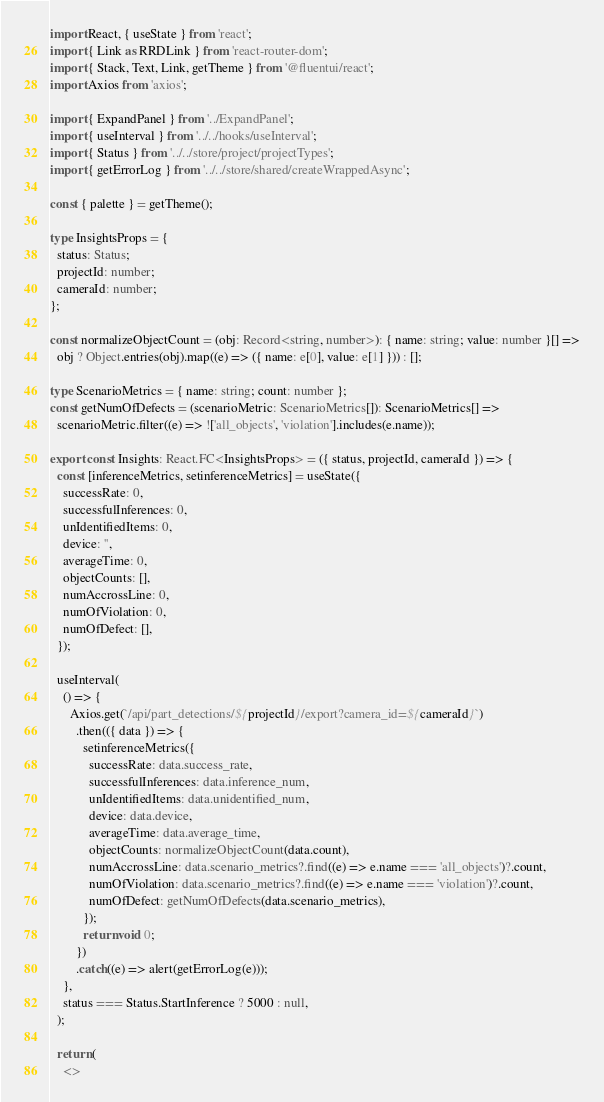<code> <loc_0><loc_0><loc_500><loc_500><_TypeScript_>import React, { useState } from 'react';
import { Link as RRDLink } from 'react-router-dom';
import { Stack, Text, Link, getTheme } from '@fluentui/react';
import Axios from 'axios';

import { ExpandPanel } from '../ExpandPanel';
import { useInterval } from '../../hooks/useInterval';
import { Status } from '../../store/project/projectTypes';
import { getErrorLog } from '../../store/shared/createWrappedAsync';

const { palette } = getTheme();

type InsightsProps = {
  status: Status;
  projectId: number;
  cameraId: number;
};

const normalizeObjectCount = (obj: Record<string, number>): { name: string; value: number }[] =>
  obj ? Object.entries(obj).map((e) => ({ name: e[0], value: e[1] })) : [];

type ScenarioMetrics = { name: string; count: number };
const getNumOfDefects = (scenarioMetric: ScenarioMetrics[]): ScenarioMetrics[] =>
  scenarioMetric.filter((e) => !['all_objects', 'violation'].includes(e.name));

export const Insights: React.FC<InsightsProps> = ({ status, projectId, cameraId }) => {
  const [inferenceMetrics, setinferenceMetrics] = useState({
    successRate: 0,
    successfulInferences: 0,
    unIdentifiedItems: 0,
    device: '',
    averageTime: 0,
    objectCounts: [],
    numAccrossLine: 0,
    numOfViolation: 0,
    numOfDefect: [],
  });

  useInterval(
    () => {
      Axios.get(`/api/part_detections/${projectId}/export?camera_id=${cameraId}`)
        .then(({ data }) => {
          setinferenceMetrics({
            successRate: data.success_rate,
            successfulInferences: data.inference_num,
            unIdentifiedItems: data.unidentified_num,
            device: data.device,
            averageTime: data.average_time,
            objectCounts: normalizeObjectCount(data.count),
            numAccrossLine: data.scenario_metrics?.find((e) => e.name === 'all_objects')?.count,
            numOfViolation: data.scenario_metrics?.find((e) => e.name === 'violation')?.count,
            numOfDefect: getNumOfDefects(data.scenario_metrics),
          });
          return void 0;
        })
        .catch((e) => alert(getErrorLog(e)));
    },
    status === Status.StartInference ? 5000 : null,
  );

  return (
    <></code> 